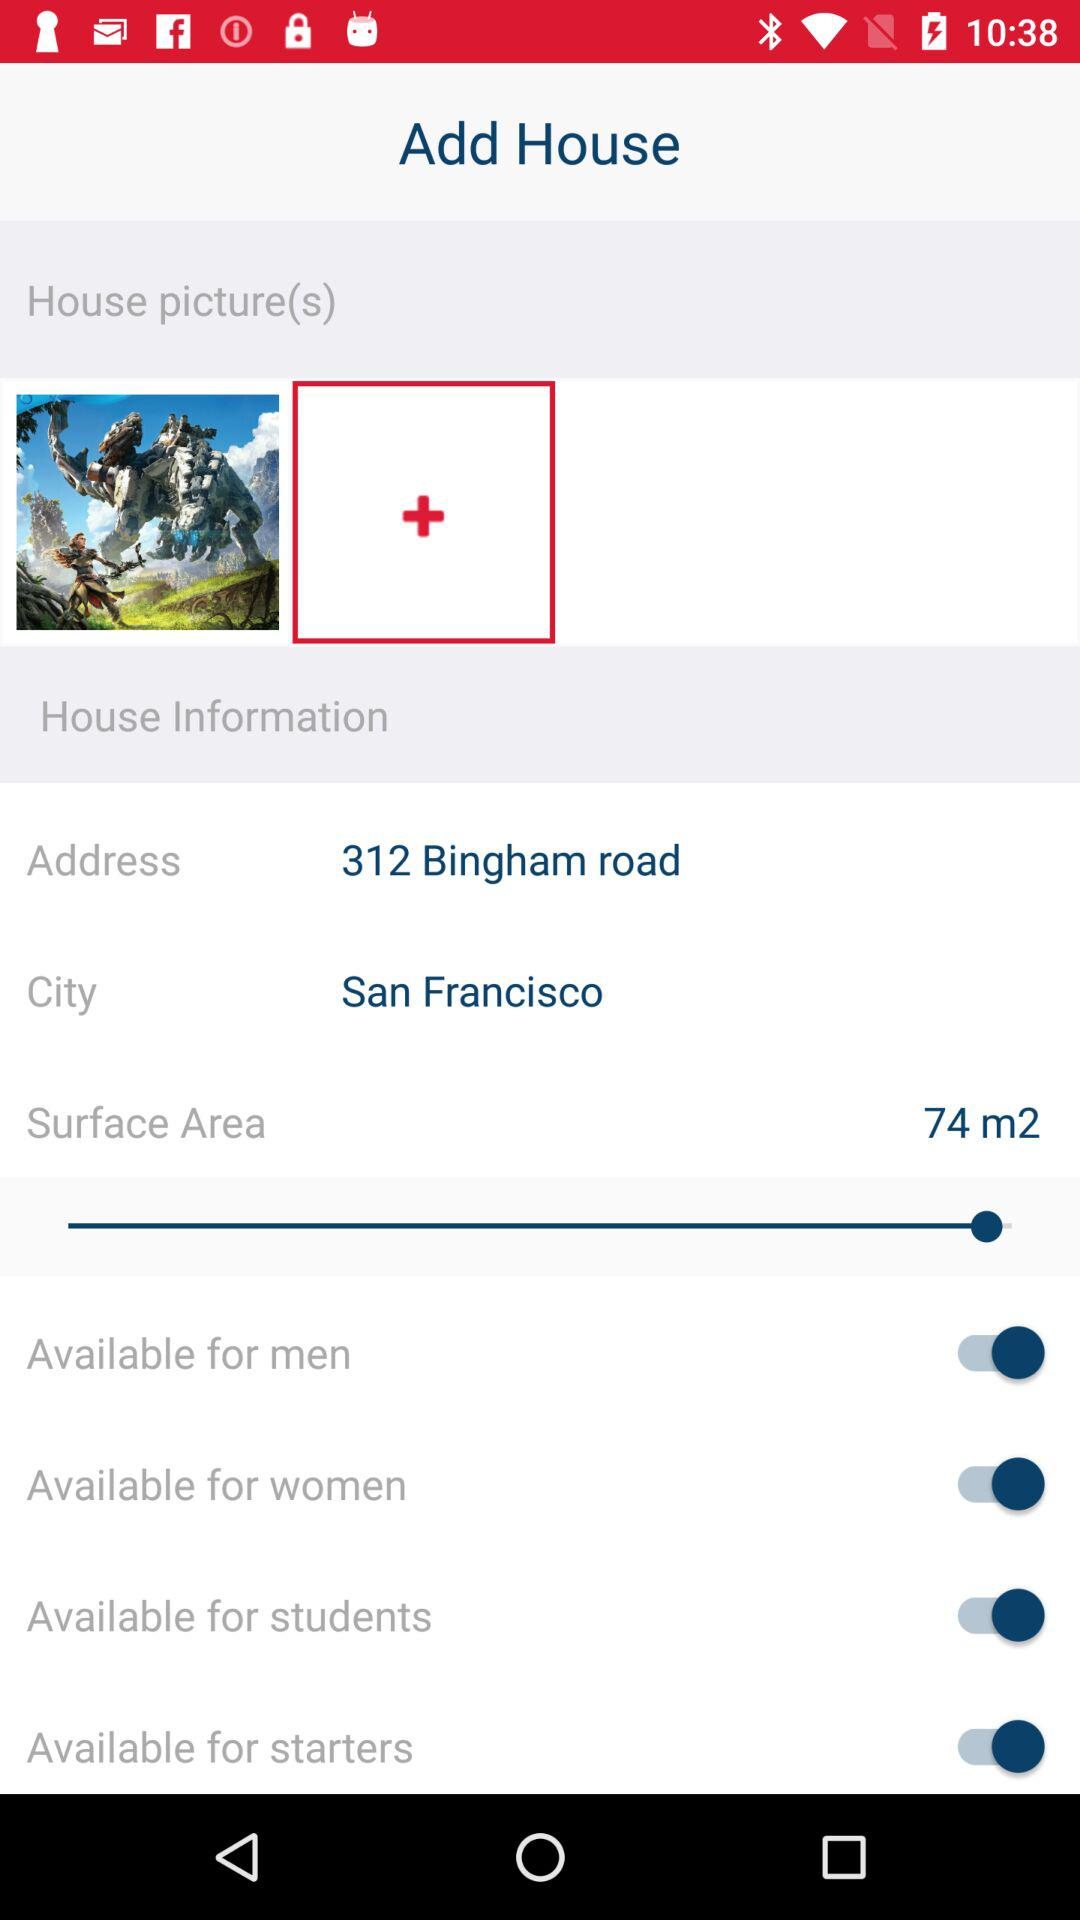What is the location? The location is 312 Bingham Road, San Francisco. 